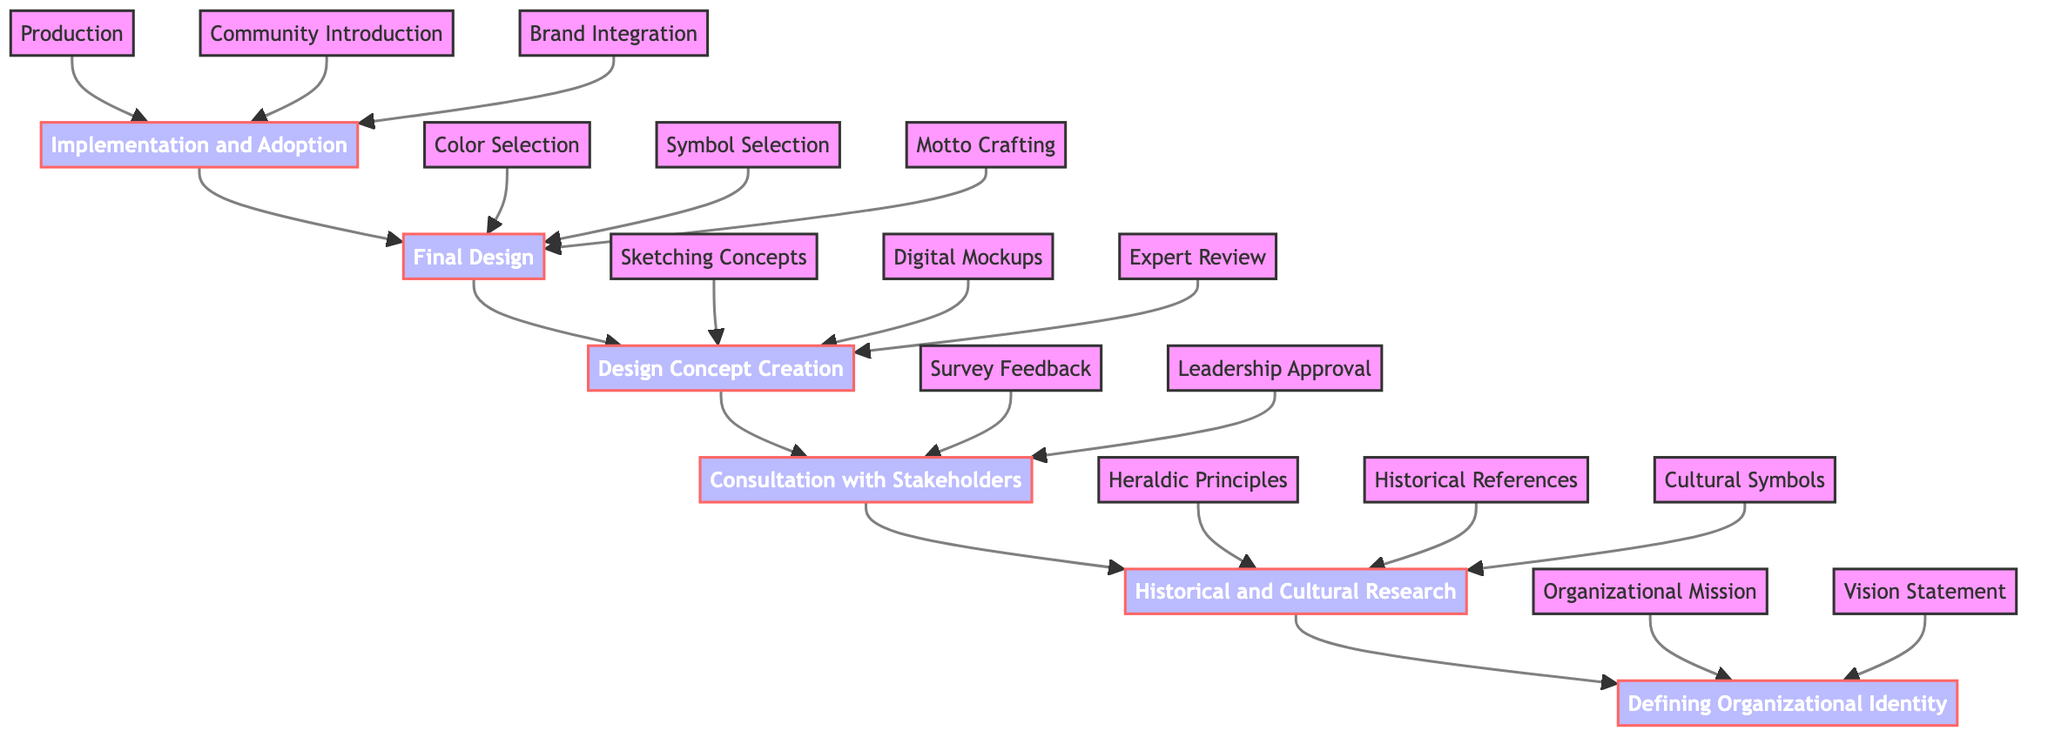What is the highest level in the flow chart? The highest level is marked by "Implementation and Adoption," which is the first node at the top.
Answer: Implementation and Adoption How many main segments are in the flow chart? There are six main segments represented as nodes within the flow chart: Implementation and Adoption, Final Design, Design Concept Creation, Consultation with Stakeholders, Historical and Cultural Research, and Defining Organizational Identity.
Answer: 6 What flows into the "Final Design" step? The "Final Design" step receives input from the "Design Concept Creation," consistent with the directional flow from bottom to top in the chart.
Answer: Design Concept Creation What are the three specific actions under "Production"? The three specific actions under "Production" that flow from it are "Community Introduction" and "Brand Integration," all of which are part of the implementation phase.
Answer: Community Introduction, Brand Integration Which step follows "Historical and Cultural Research"? The step that follows "Historical and Cultural Research" is "Consultation with Stakeholders," indicating a sequential process of gathering information before involving stakeholders.
Answer: Consultation with Stakeholders What is the relationship between "Symbol Selection" and "Final Design"? "Symbol Selection" is one of the components directly flowing into "Final Design," indicating that it is a necessary part of finalizing the coat of arms design.
Answer: Direct input How many specific actions are listed under "Design Concept Creation"? There are three specific actions listed under "Design Concept Creation," namely "Sketching Concepts," "Digital Mockups," and "Expert Review," indicating a detailed creative process.
Answer: 3 Which node comes before "Defining Organizational Identity"? The node that comes before "Defining Organizational Identity" is "Historical and Cultural Research," establishing a foundation of knowledge before defining the organization's identity.
Answer: Historical and Cultural Research What is the last action in "Final Design"? The last action in "Final Design" is "Motto Crafting," suggesting this step is critical in encapsulating the organization's ethos through a concise statement.
Answer: Motto Crafting 